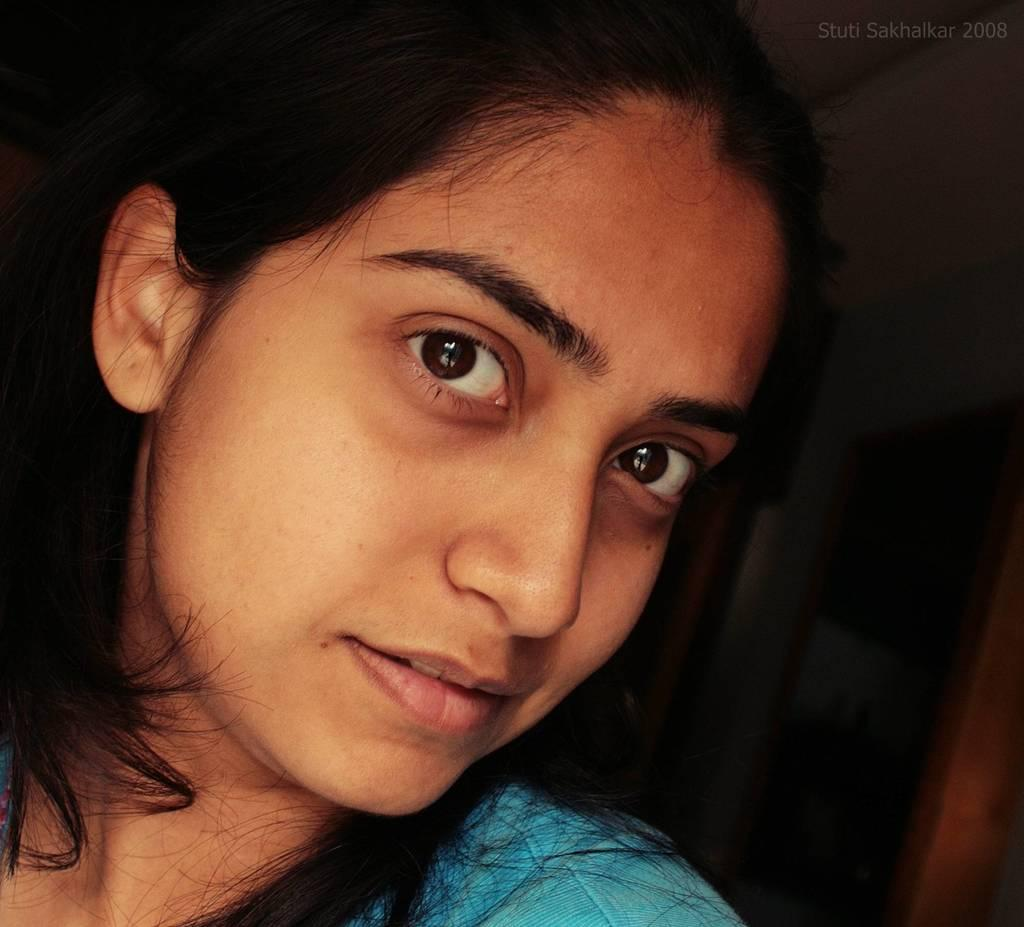Who is present in the image? There is a woman in the image. What expression does the woman have? The woman is smiling. What can be seen in the background of the image? There is a wall and a door in the background of the image. How would you describe the lighting in the image? The background of the image is dark. What type of scent can be detected in the image? There is no information about any scent in the image, so it cannot be determined. What kind of feast is being prepared in the image? There is no indication of a feast or any food preparation in the image. 